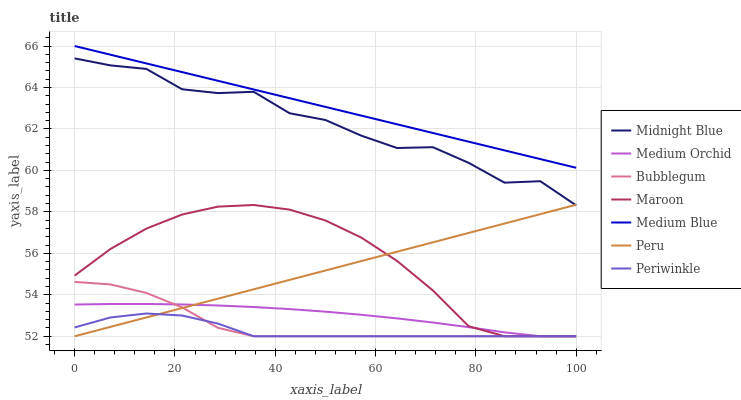Does Periwinkle have the minimum area under the curve?
Answer yes or no. Yes. Does Medium Blue have the maximum area under the curve?
Answer yes or no. Yes. Does Medium Orchid have the minimum area under the curve?
Answer yes or no. No. Does Medium Orchid have the maximum area under the curve?
Answer yes or no. No. Is Peru the smoothest?
Answer yes or no. Yes. Is Midnight Blue the roughest?
Answer yes or no. Yes. Is Medium Orchid the smoothest?
Answer yes or no. No. Is Medium Orchid the roughest?
Answer yes or no. No. Does Medium Blue have the lowest value?
Answer yes or no. No. Does Medium Blue have the highest value?
Answer yes or no. Yes. Does Medium Orchid have the highest value?
Answer yes or no. No. Is Bubblegum less than Medium Blue?
Answer yes or no. Yes. Is Medium Blue greater than Midnight Blue?
Answer yes or no. Yes. Does Bubblegum intersect Medium Orchid?
Answer yes or no. Yes. Is Bubblegum less than Medium Orchid?
Answer yes or no. No. Is Bubblegum greater than Medium Orchid?
Answer yes or no. No. Does Bubblegum intersect Medium Blue?
Answer yes or no. No. 